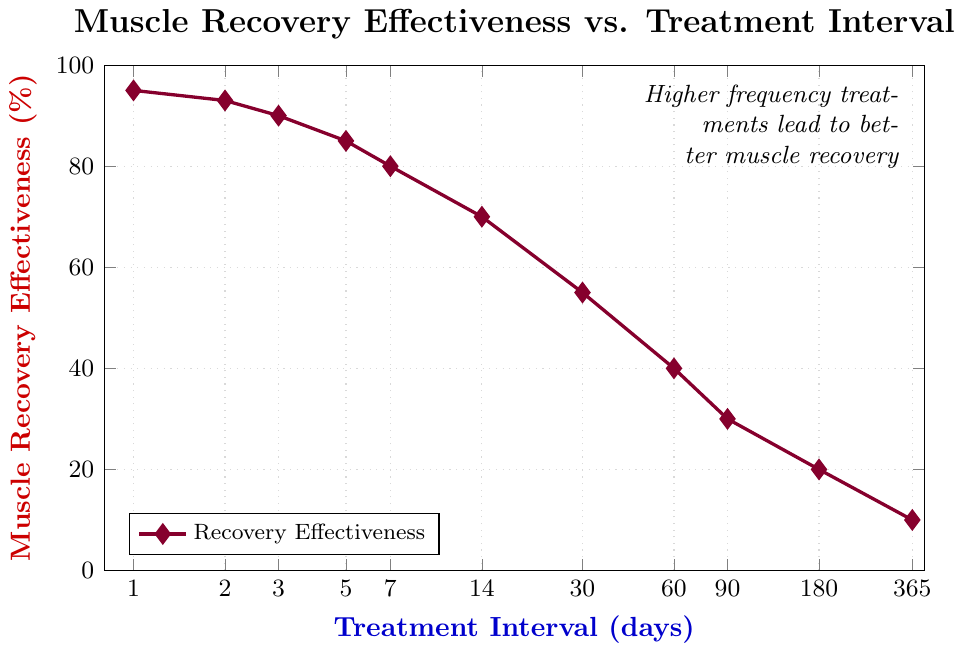What's the treatment interval where muscle recovery effectiveness starts to significantly drop below 80%? Observing the plot, muscle recovery effectiveness is above 80% at 7 days and below 80% at 14 days. Therefore, the significant drop occurs at intervals greater than 7 days.
Answer: 14 days At which treatment interval does muscle recovery effectiveness drop to its lowest point? Looking at the figure, the lowest percentage of muscle recovery effectiveness is at the 365-day interval, which is 10%.
Answer: 365 days How much does muscle recovery effectiveness decrease when moving from a 1-day interval to a 30-day interval? The effectiveness is 95% at a 1-day interval and 55% at a 30-day interval. The decrease is 95 - 55 = 40%.
Answer: 40% What is the average muscle recovery effectiveness for intervals of 1, 7, and 30 days? The percentages are 95%, 80%, and 55%. The average is (95 + 80 + 55) / 3 = 76.67%.
Answer: 76.67% Compare the muscle recovery effectiveness at 60 days and 180 days. Which interval shows better effectiveness? At 60 days, the effectiveness is 40%, and at 180 days, it is 20%. 60 days shows better effectiveness.
Answer: 60 days Identify the treatment interval which shows an effectiveness closest to 50%. Observing the plot, the interval closest to 50% effectiveness is at 30 days with 55%.
Answer: 30 days What is the difference in muscle recovery effectiveness between the 3-day interval and the 365-day interval? The effectiveness at 3 days is 90%, while at 365 days it is 10%. The difference is 90 - 10 = 80%.
Answer: 80% Estimate the effectiveness if the treatment interval is halved from 14 days to 7 days. At 14 days, the effectiveness is 70%, and at 7 days, it is 80%. Therefore, the effectiveness increases by 10% when the interval is halved from 14 to 7 days.
Answer: 80% What is the visual color used to denote muscle recovery effectiveness in the chart? The color used to denote the recovery effectiveness in the figure is purple.
Answer: purple 